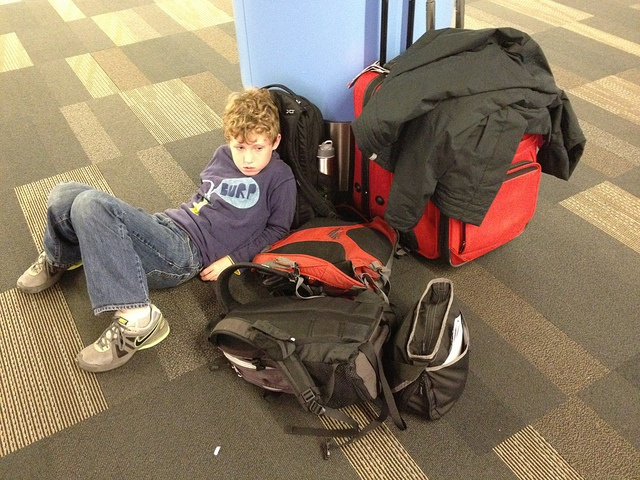Describe the objects in this image and their specific colors. I can see people in lightyellow, gray, darkgray, black, and tan tones, backpack in lightyellow, black, and gray tones, suitcase in lightyellow, salmon, black, brown, and maroon tones, handbag in lightyellow, black, and gray tones, and backpack in lightyellow, black, maroon, red, and salmon tones in this image. 